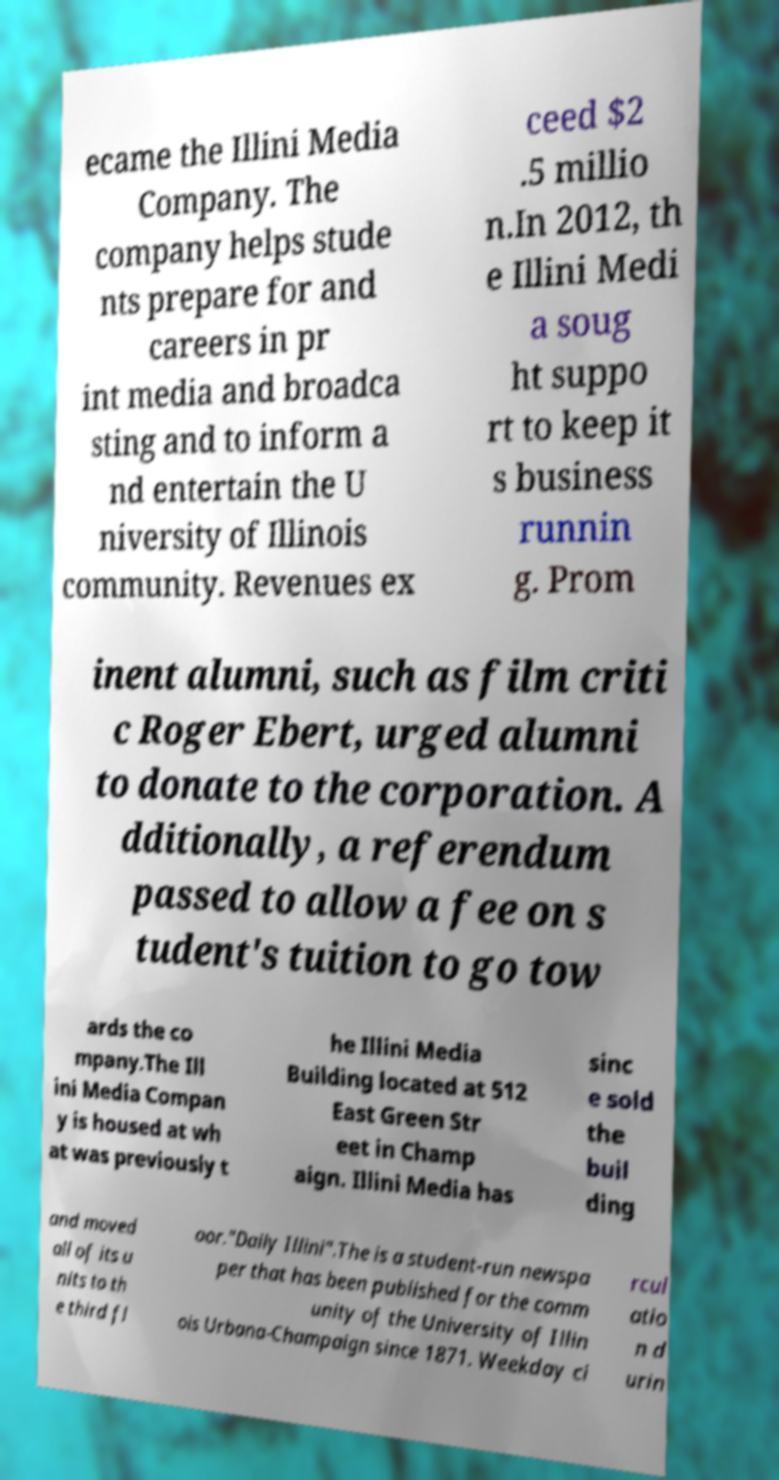Please read and relay the text visible in this image. What does it say? ecame the Illini Media Company. The company helps stude nts prepare for and careers in pr int media and broadca sting and to inform a nd entertain the U niversity of Illinois community. Revenues ex ceed $2 .5 millio n.In 2012, th e Illini Medi a soug ht suppo rt to keep it s business runnin g. Prom inent alumni, such as film criti c Roger Ebert, urged alumni to donate to the corporation. A dditionally, a referendum passed to allow a fee on s tudent's tuition to go tow ards the co mpany.The Ill ini Media Compan y is housed at wh at was previously t he Illini Media Building located at 512 East Green Str eet in Champ aign. Illini Media has sinc e sold the buil ding and moved all of its u nits to th e third fl oor."Daily Illini".The is a student-run newspa per that has been published for the comm unity of the University of Illin ois Urbana-Champaign since 1871. Weekday ci rcul atio n d urin 